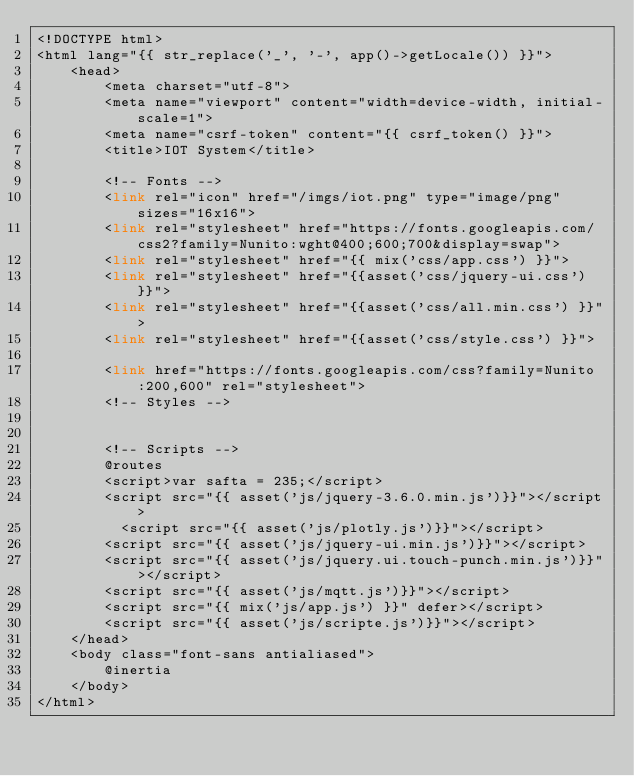<code> <loc_0><loc_0><loc_500><loc_500><_PHP_><!DOCTYPE html>
<html lang="{{ str_replace('_', '-', app()->getLocale()) }}">
    <head>
        <meta charset="utf-8">
        <meta name="viewport" content="width=device-width, initial-scale=1">
        <meta name="csrf-token" content="{{ csrf_token() }}">
        <title>IOT System</title>

        <!-- Fonts -->
        <link rel="icon" href="/imgs/iot.png" type="image/png" sizes="16x16">
        <link rel="stylesheet" href="https://fonts.googleapis.com/css2?family=Nunito:wght@400;600;700&display=swap">
        <link rel="stylesheet" href="{{ mix('css/app.css') }}">
        <link rel="stylesheet" href="{{asset('css/jquery-ui.css') }}">
        <link rel="stylesheet" href="{{asset('css/all.min.css') }}">
        <link rel="stylesheet" href="{{asset('css/style.css') }}">

        <link href="https://fonts.googleapis.com/css?family=Nunito:200,600" rel="stylesheet">
        <!-- Styles -->
       

        <!-- Scripts -->
        @routes
        <script>var safta = 235;</script>
        <script src="{{ asset('js/jquery-3.6.0.min.js')}}"></script>
          <script src="{{ asset('js/plotly.js')}}"></script>
        <script src="{{ asset('js/jquery-ui.min.js')}}"></script>
        <script src="{{ asset('js/jquery.ui.touch-punch.min.js')}}"></script>
        <script src="{{ asset('js/mqtt.js')}}"></script>
        <script src="{{ mix('js/app.js') }}" defer></script>
        <script src="{{ asset('js/scripte.js')}}"></script>
    </head>
    <body class="font-sans antialiased">
        @inertia
    </body>
</html>
</code> 